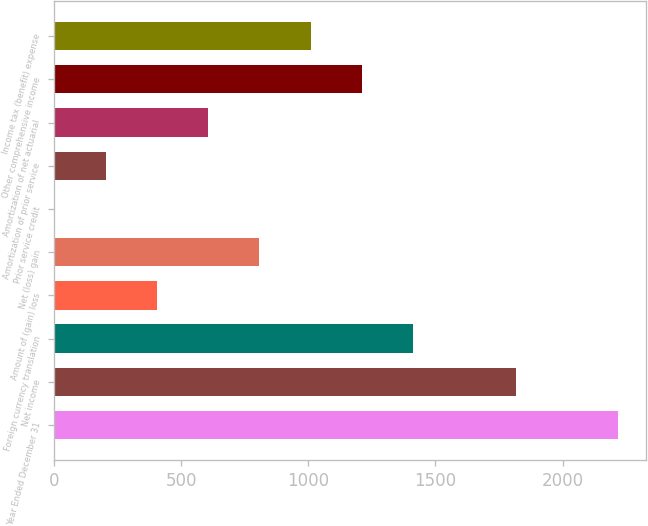<chart> <loc_0><loc_0><loc_500><loc_500><bar_chart><fcel>Year Ended December 31<fcel>Net income<fcel>Foreign currency translation<fcel>Amount of (gain) loss<fcel>Net (loss) gain<fcel>Prior service credit<fcel>Amortization of prior service<fcel>Amortization of net actuarial<fcel>Other comprehensive income<fcel>Income tax (benefit) expense<nl><fcel>2218.6<fcel>1815.4<fcel>1412.2<fcel>404.2<fcel>807.4<fcel>1<fcel>202.6<fcel>605.8<fcel>1210.6<fcel>1009<nl></chart> 